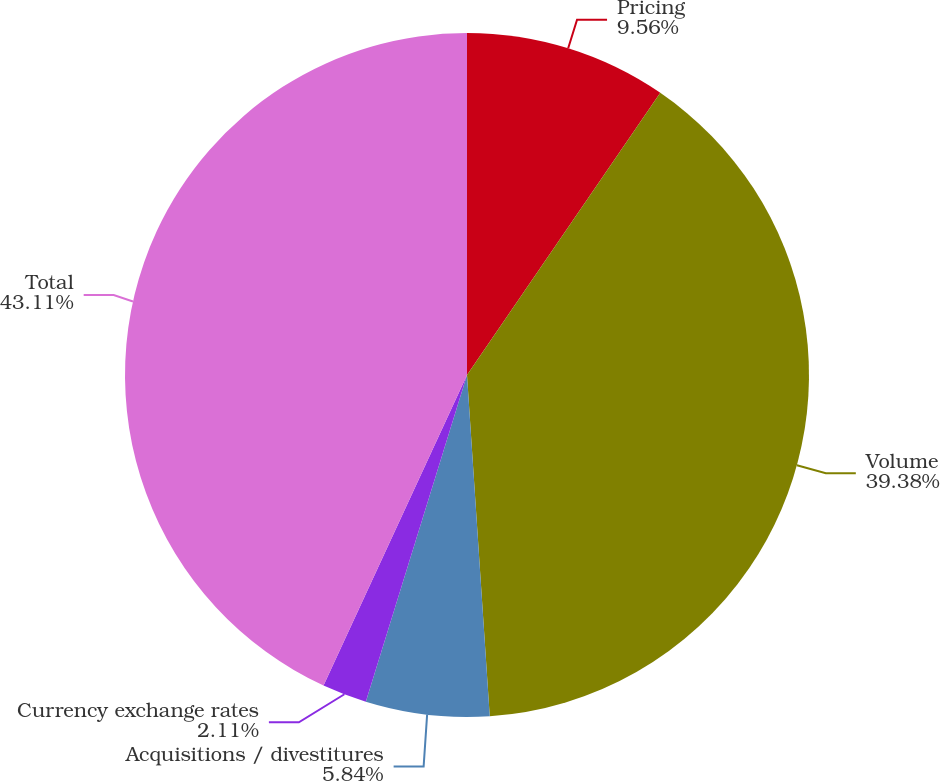<chart> <loc_0><loc_0><loc_500><loc_500><pie_chart><fcel>Pricing<fcel>Volume<fcel>Acquisitions / divestitures<fcel>Currency exchange rates<fcel>Total<nl><fcel>9.56%<fcel>39.38%<fcel>5.84%<fcel>2.11%<fcel>43.11%<nl></chart> 